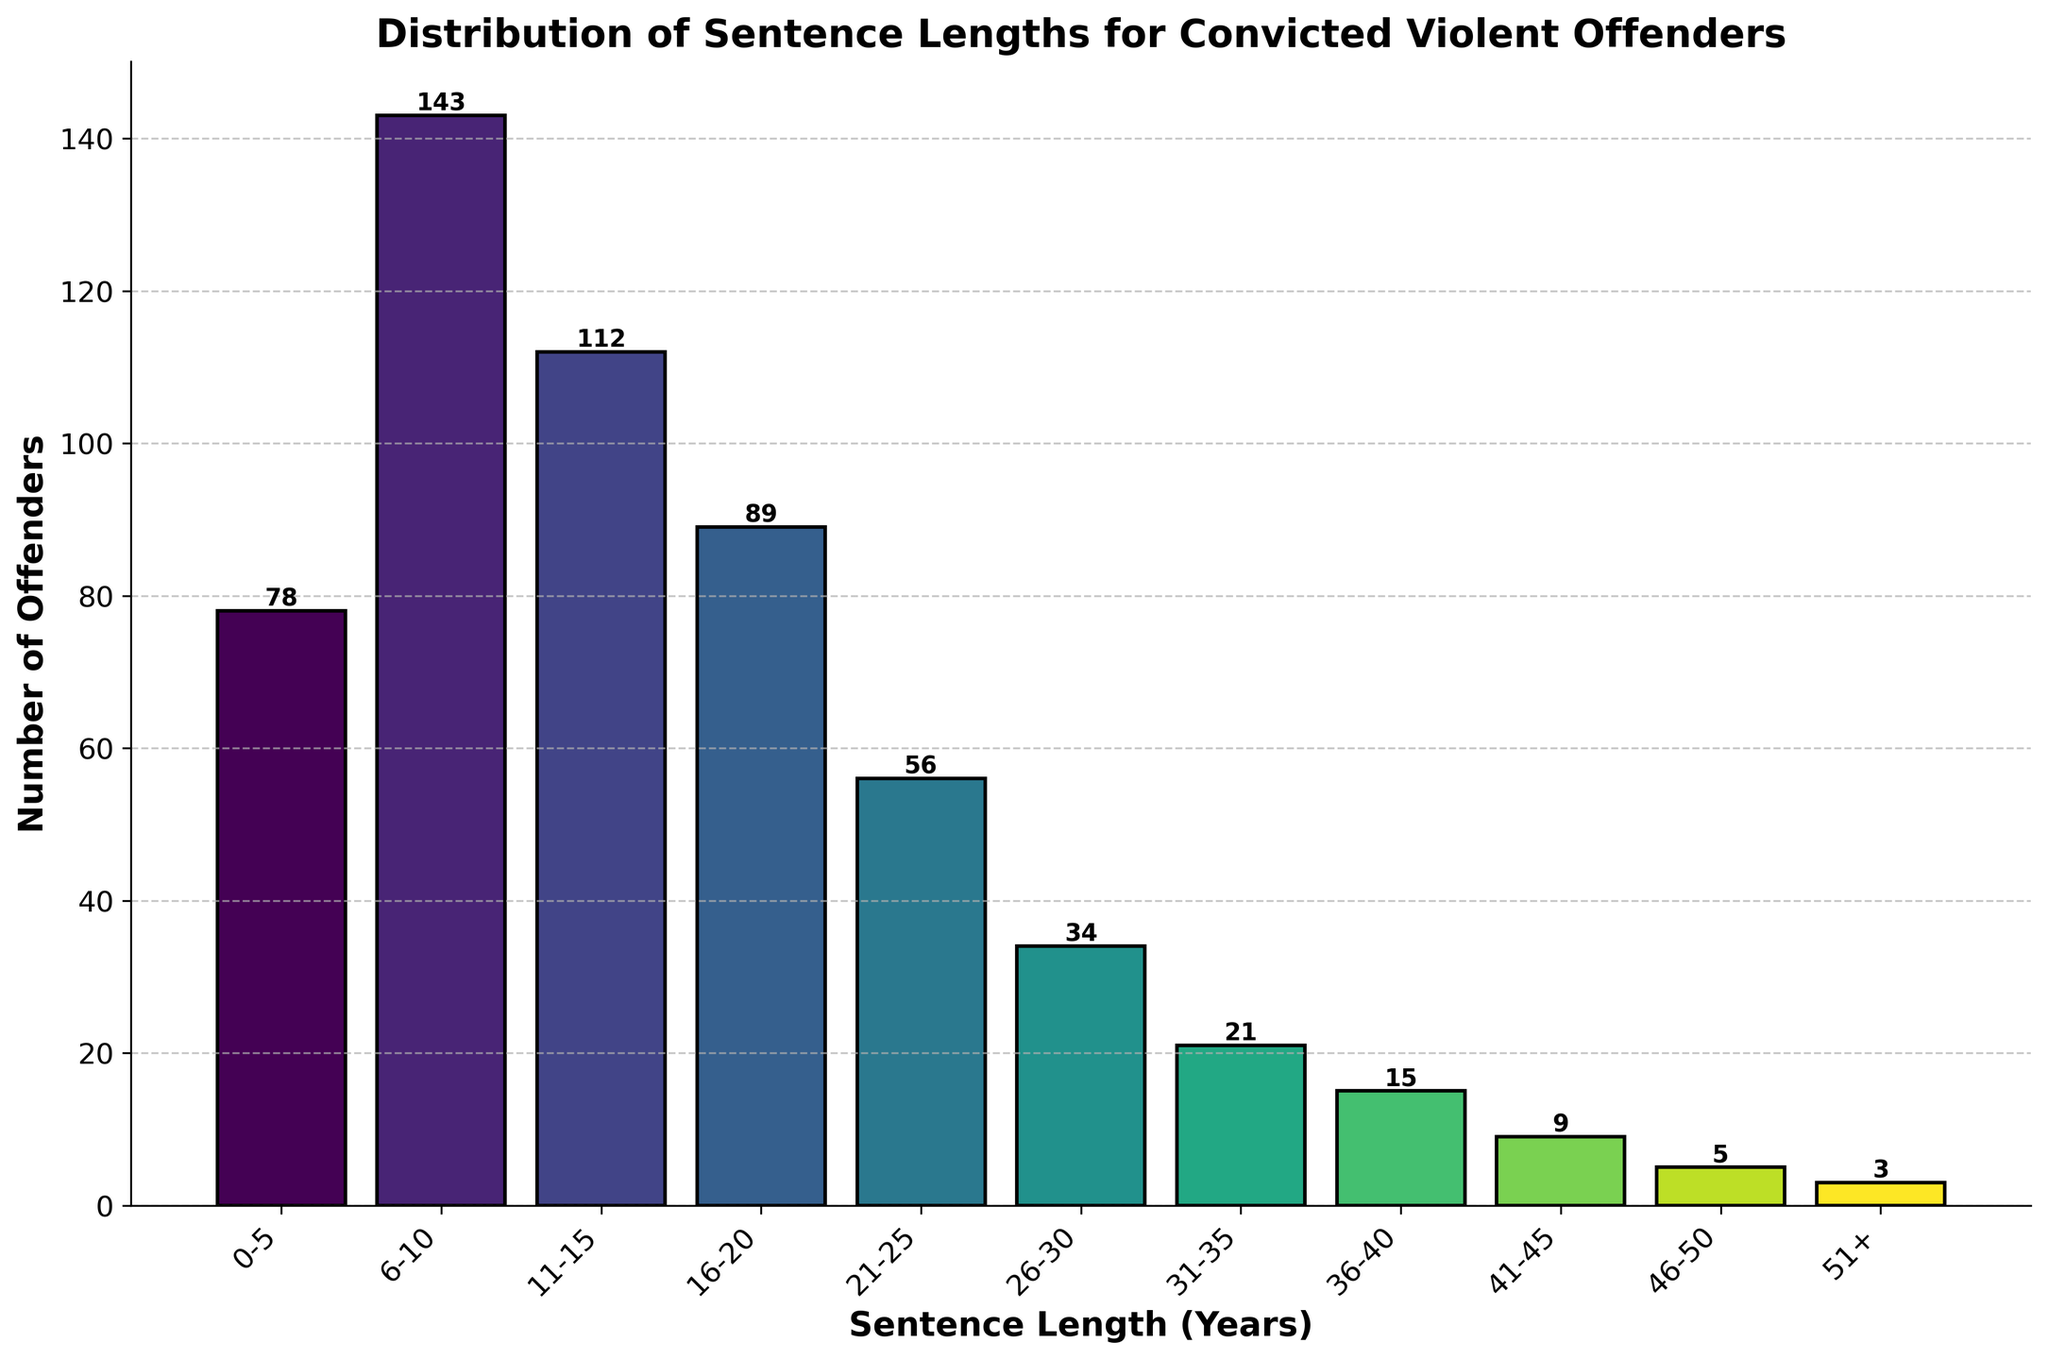What's the title of the figure? The title of the figure is the text displayed prominently at the top of the chart. It provides a brief summary of what the chart is about.
Answer: Distribution of Sentence Lengths for Convicted Violent Offenders What is the label for the x-axis? The x-axis label is the text shown along the horizontal axis, indicating what each value on this axis represents.
Answer: Sentence Length (Years) What is the label for the y-axis? The y-axis label is the text shown along the vertical axis, indicating what each value on this axis represents.
Answer: Number of Offenders Which sentence length category has the highest number of offenders? By looking at the heights of the bars, the tallest bar corresponds to the category with the highest number of offenders.
Answer: 6-10 years Which sentence length category has the least number of offenders? By looking at the heights of the bars, the shortest bar corresponds to the category with the least number of offenders.
Answer: 51+ years How many offenders were sentenced to 11-15 years? Reference the bar corresponding to the 11-15 years category and read the height or the number shown above it.
Answer: 112 What's the sum of offenders sentenced to 0-5 years and 6-10 years? Add the number of offenders in the 0-5 years category to the number in the 6-10 years category. 78 + 143 = 221
Answer: 221 What's the difference in the number of offenders between those sentenced to 16-20 years and 21-25 years? Subtract the number of offenders in the 21-25 years category from the number in the 16-20 years category. 89 - 56 = 33
Answer: 33 How many offenders were sentenced to 51+ years? Reference the bar corresponding to the 51+ years category and read the height or the number shown above it.
Answer: 3 Compare the number of offenders sentenced to 26-30 years and 31-35 years: which category has more? Compare the heights of the bars corresponding to the 26-30 years and 31-35 years categories.
Answer: 26-30 years 